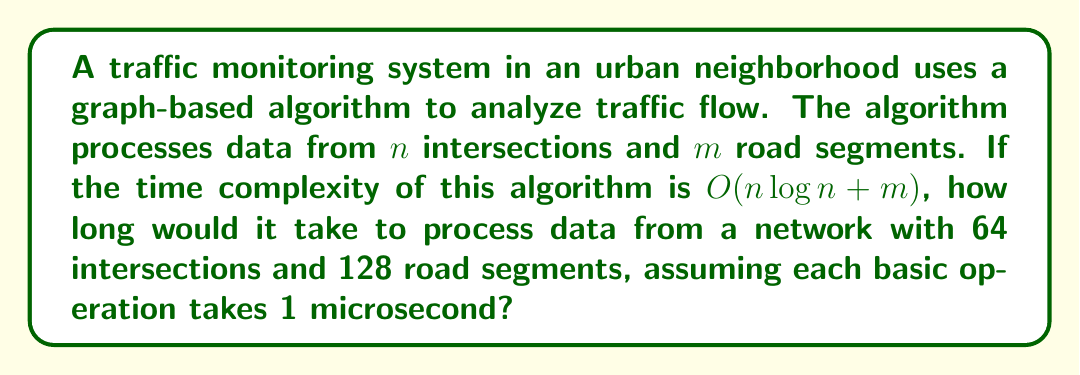Give your solution to this math problem. Let's break this down step-by-step:

1) The time complexity is $O(n \log n + m)$, where:
   - $n$ is the number of intersections (64)
   - $m$ is the number of road segments (128)

2) We need to calculate $n \log n + m$:
   
   $n \log n = 64 \log 64$
   
   $\log 64 = 6$ (since $2^6 = 64$)
   
   So, $64 \log 64 = 64 * 6 = 384$

3) Now we add $m$:
   
   $384 + 128 = 512$

4) This means the algorithm will perform approximately 512 basic operations.

5) Since each basic operation takes 1 microsecond:
   
   Total time = $512 * 1$ microsecond = 512 microseconds

This analysis helps us understand how the algorithm's performance scales with the size of the traffic network. For a concerned parent, this information could be valuable in understanding how quickly traffic patterns can be analyzed and potentially dangerous situations identified.
Answer: 512 microseconds 